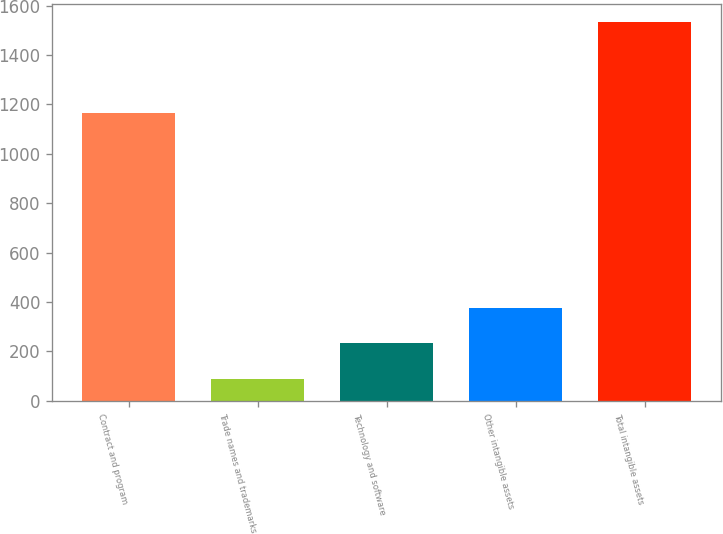Convert chart to OTSL. <chart><loc_0><loc_0><loc_500><loc_500><bar_chart><fcel>Contract and program<fcel>Trade names and trademarks<fcel>Technology and software<fcel>Other intangible assets<fcel>Total intangible assets<nl><fcel>1165<fcel>87<fcel>231.5<fcel>376<fcel>1532<nl></chart> 